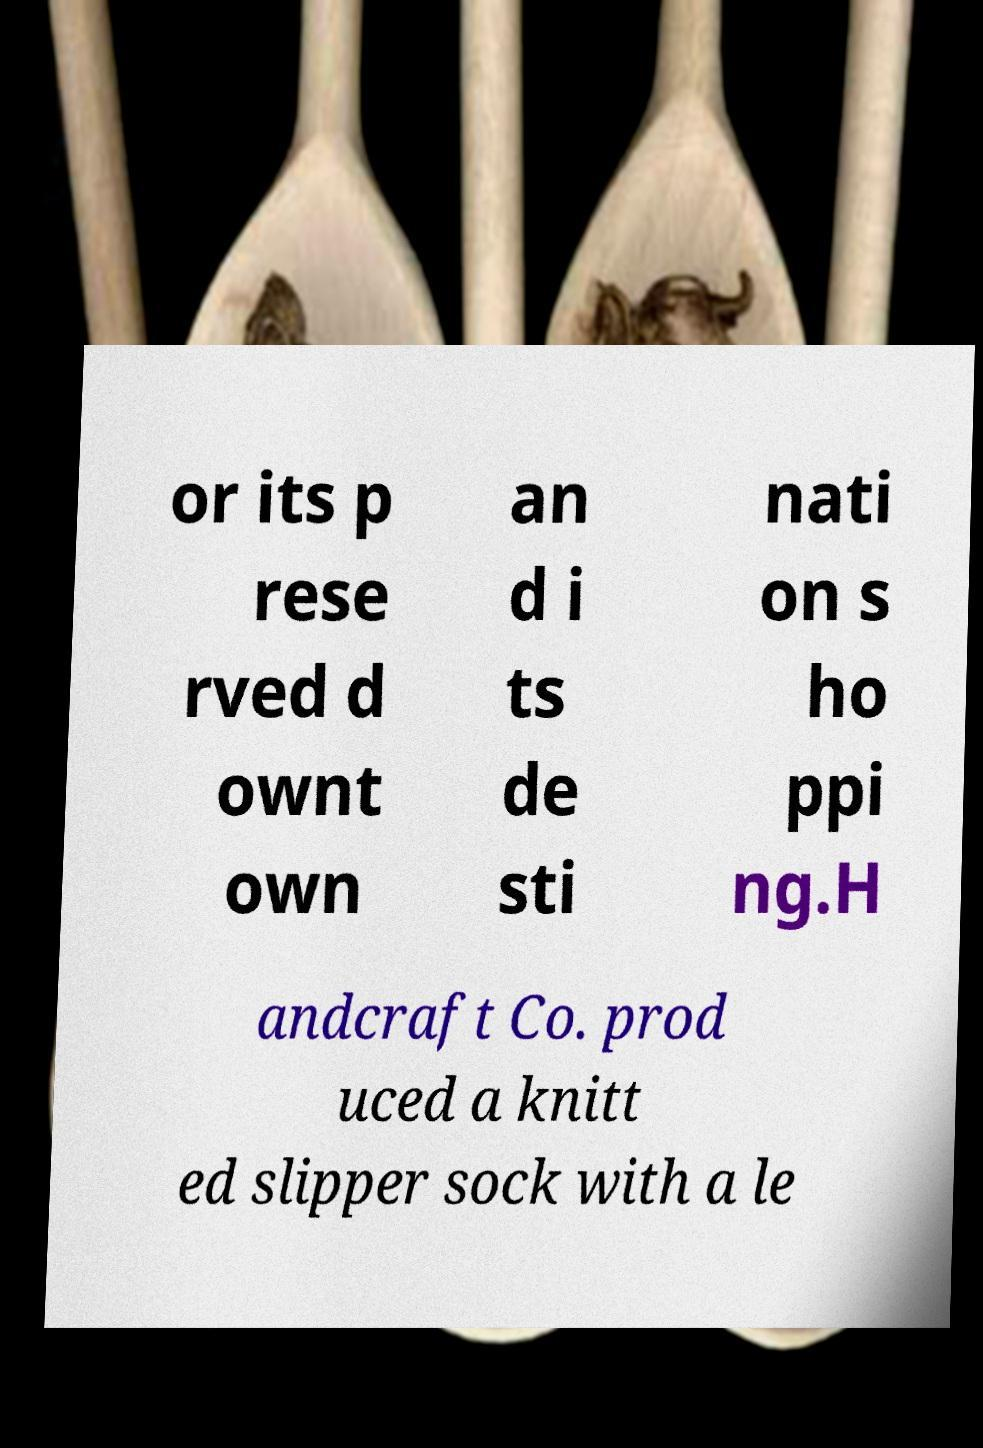Can you accurately transcribe the text from the provided image for me? or its p rese rved d ownt own an d i ts de sti nati on s ho ppi ng.H andcraft Co. prod uced a knitt ed slipper sock with a le 